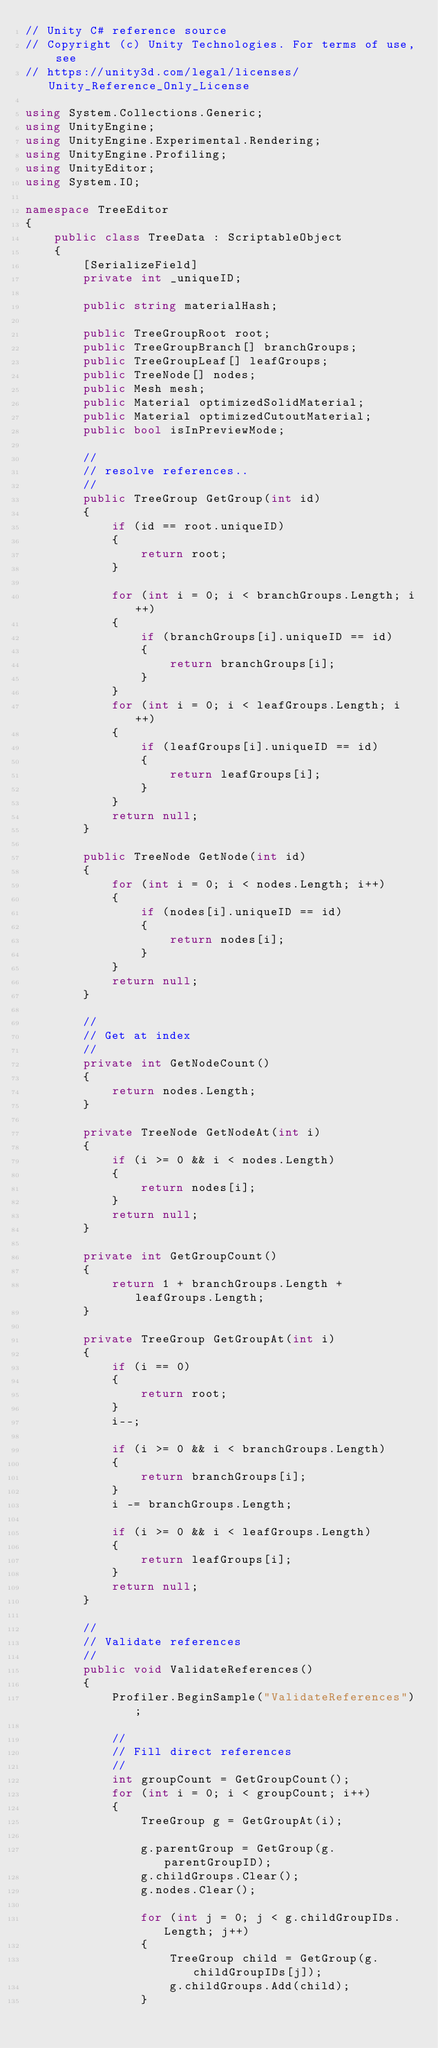<code> <loc_0><loc_0><loc_500><loc_500><_C#_>// Unity C# reference source
// Copyright (c) Unity Technologies. For terms of use, see
// https://unity3d.com/legal/licenses/Unity_Reference_Only_License

using System.Collections.Generic;
using UnityEngine;
using UnityEngine.Experimental.Rendering;
using UnityEngine.Profiling;
using UnityEditor;
using System.IO;

namespace TreeEditor
{
    public class TreeData : ScriptableObject
    {
        [SerializeField]
        private int _uniqueID;

        public string materialHash;

        public TreeGroupRoot root;
        public TreeGroupBranch[] branchGroups;
        public TreeGroupLeaf[] leafGroups;
        public TreeNode[] nodes;
        public Mesh mesh;
        public Material optimizedSolidMaterial;
        public Material optimizedCutoutMaterial;
        public bool isInPreviewMode;

        //
        // resolve references..
        //
        public TreeGroup GetGroup(int id)
        {
            if (id == root.uniqueID)
            {
                return root;
            }

            for (int i = 0; i < branchGroups.Length; i++)
            {
                if (branchGroups[i].uniqueID == id)
                {
                    return branchGroups[i];
                }
            }
            for (int i = 0; i < leafGroups.Length; i++)
            {
                if (leafGroups[i].uniqueID == id)
                {
                    return leafGroups[i];
                }
            }
            return null;
        }

        public TreeNode GetNode(int id)
        {
            for (int i = 0; i < nodes.Length; i++)
            {
                if (nodes[i].uniqueID == id)
                {
                    return nodes[i];
                }
            }
            return null;
        }

        //
        // Get at index
        //
        private int GetNodeCount()
        {
            return nodes.Length;
        }

        private TreeNode GetNodeAt(int i)
        {
            if (i >= 0 && i < nodes.Length)
            {
                return nodes[i];
            }
            return null;
        }

        private int GetGroupCount()
        {
            return 1 + branchGroups.Length + leafGroups.Length;
        }

        private TreeGroup GetGroupAt(int i)
        {
            if (i == 0)
            {
                return root;
            }
            i--;

            if (i >= 0 && i < branchGroups.Length)
            {
                return branchGroups[i];
            }
            i -= branchGroups.Length;

            if (i >= 0 && i < leafGroups.Length)
            {
                return leafGroups[i];
            }
            return null;
        }

        //
        // Validate references
        //
        public void ValidateReferences()
        {
            Profiler.BeginSample("ValidateReferences");

            //
            // Fill direct references
            //
            int groupCount = GetGroupCount();
            for (int i = 0; i < groupCount; i++)
            {
                TreeGroup g = GetGroupAt(i);

                g.parentGroup = GetGroup(g.parentGroupID);
                g.childGroups.Clear();
                g.nodes.Clear();

                for (int j = 0; j < g.childGroupIDs.Length; j++)
                {
                    TreeGroup child = GetGroup(g.childGroupIDs[j]);
                    g.childGroups.Add(child);
                }</code> 